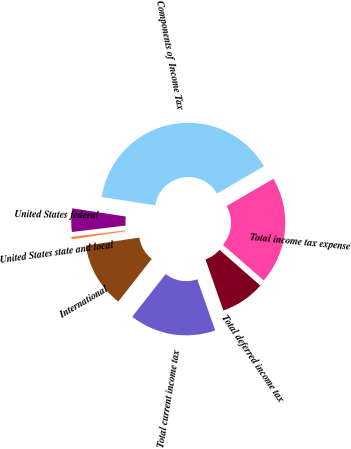<chart> <loc_0><loc_0><loc_500><loc_500><pie_chart><fcel>Components of Income Tax<fcel>United States federal<fcel>United States state and local<fcel>International<fcel>Total current income tax<fcel>Total deferred income tax<fcel>Total income tax expense<nl><fcel>39.19%<fcel>4.32%<fcel>0.45%<fcel>12.07%<fcel>15.95%<fcel>8.2%<fcel>19.82%<nl></chart> 